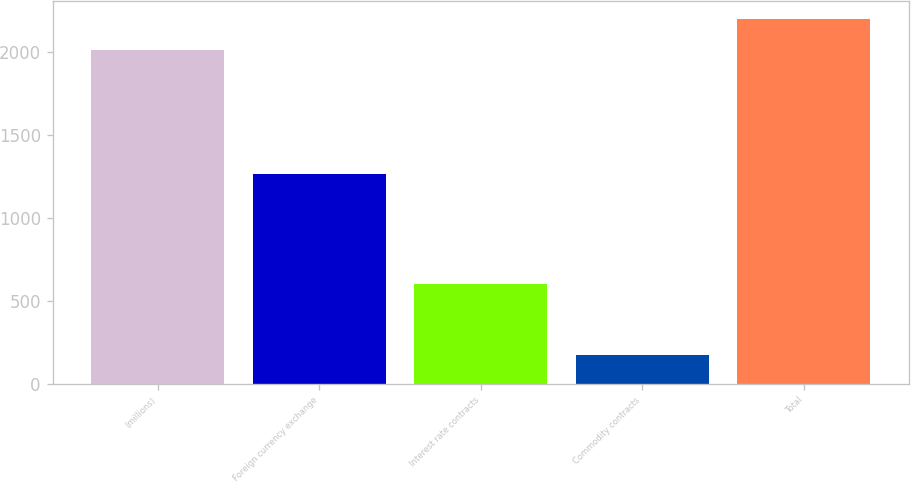<chart> <loc_0><loc_0><loc_500><loc_500><bar_chart><fcel>(millions)<fcel>Foreign currency exchange<fcel>Interest rate contracts<fcel>Commodity contracts<fcel>Total<nl><fcel>2011<fcel>1265<fcel>600<fcel>175<fcel>2197.5<nl></chart> 